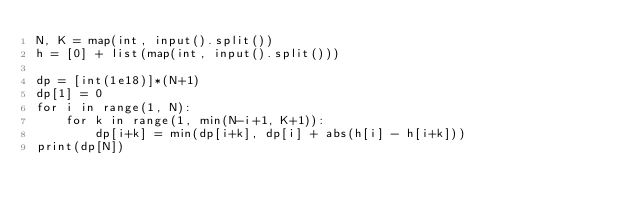Convert code to text. <code><loc_0><loc_0><loc_500><loc_500><_Python_>N, K = map(int, input().split())
h = [0] + list(map(int, input().split()))

dp = [int(1e18)]*(N+1)
dp[1] = 0
for i in range(1, N):
    for k in range(1, min(N-i+1, K+1)):
        dp[i+k] = min(dp[i+k], dp[i] + abs(h[i] - h[i+k]))
print(dp[N])
</code> 